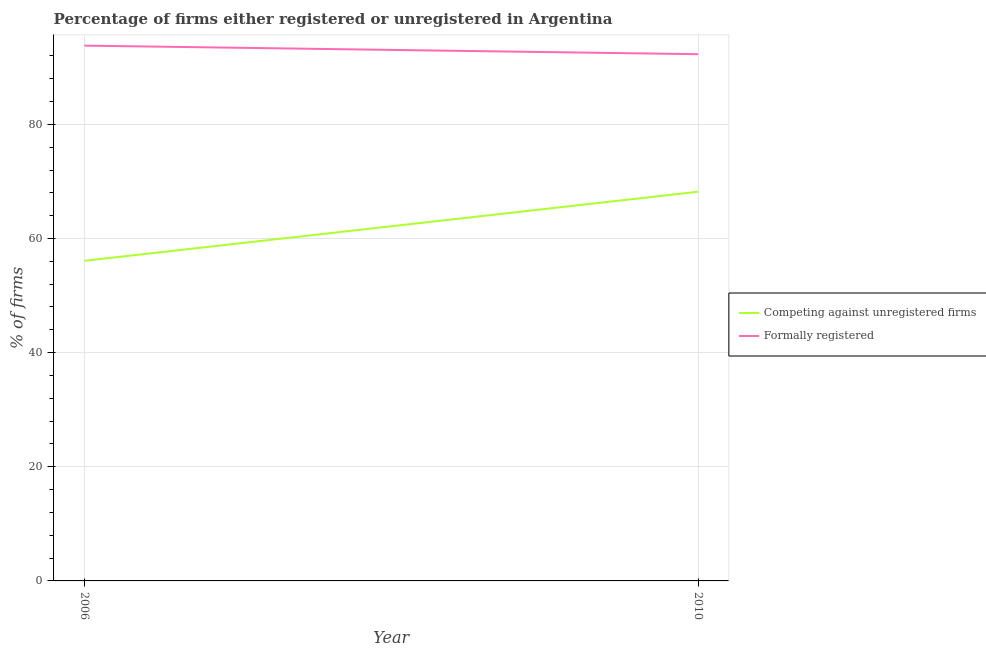What is the percentage of formally registered firms in 2010?
Ensure brevity in your answer.  92.3. Across all years, what is the maximum percentage of formally registered firms?
Keep it short and to the point. 93.8. Across all years, what is the minimum percentage of formally registered firms?
Make the answer very short. 92.3. In which year was the percentage of registered firms minimum?
Your answer should be compact. 2006. What is the total percentage of registered firms in the graph?
Give a very brief answer. 124.3. What is the difference between the percentage of registered firms in 2006 and that in 2010?
Keep it short and to the point. -12.1. What is the difference between the percentage of registered firms in 2006 and the percentage of formally registered firms in 2010?
Your answer should be compact. -36.2. What is the average percentage of formally registered firms per year?
Provide a short and direct response. 93.05. In the year 2006, what is the difference between the percentage of formally registered firms and percentage of registered firms?
Your answer should be compact. 37.7. In how many years, is the percentage of registered firms greater than 56 %?
Keep it short and to the point. 2. What is the ratio of the percentage of registered firms in 2006 to that in 2010?
Give a very brief answer. 0.82. In how many years, is the percentage of registered firms greater than the average percentage of registered firms taken over all years?
Provide a short and direct response. 1. Does the percentage of registered firms monotonically increase over the years?
Provide a short and direct response. Yes. Is the percentage of registered firms strictly greater than the percentage of formally registered firms over the years?
Keep it short and to the point. No. How are the legend labels stacked?
Make the answer very short. Vertical. What is the title of the graph?
Your answer should be very brief. Percentage of firms either registered or unregistered in Argentina. What is the label or title of the Y-axis?
Your answer should be very brief. % of firms. What is the % of firms of Competing against unregistered firms in 2006?
Your answer should be compact. 56.1. What is the % of firms in Formally registered in 2006?
Your answer should be very brief. 93.8. What is the % of firms in Competing against unregistered firms in 2010?
Your answer should be very brief. 68.2. What is the % of firms of Formally registered in 2010?
Your answer should be compact. 92.3. Across all years, what is the maximum % of firms in Competing against unregistered firms?
Give a very brief answer. 68.2. Across all years, what is the maximum % of firms of Formally registered?
Your answer should be compact. 93.8. Across all years, what is the minimum % of firms in Competing against unregistered firms?
Ensure brevity in your answer.  56.1. Across all years, what is the minimum % of firms of Formally registered?
Your response must be concise. 92.3. What is the total % of firms in Competing against unregistered firms in the graph?
Offer a terse response. 124.3. What is the total % of firms of Formally registered in the graph?
Keep it short and to the point. 186.1. What is the difference between the % of firms of Competing against unregistered firms in 2006 and that in 2010?
Your answer should be very brief. -12.1. What is the difference between the % of firms of Competing against unregistered firms in 2006 and the % of firms of Formally registered in 2010?
Ensure brevity in your answer.  -36.2. What is the average % of firms of Competing against unregistered firms per year?
Your answer should be very brief. 62.15. What is the average % of firms in Formally registered per year?
Your response must be concise. 93.05. In the year 2006, what is the difference between the % of firms of Competing against unregistered firms and % of firms of Formally registered?
Provide a short and direct response. -37.7. In the year 2010, what is the difference between the % of firms of Competing against unregistered firms and % of firms of Formally registered?
Your answer should be compact. -24.1. What is the ratio of the % of firms of Competing against unregistered firms in 2006 to that in 2010?
Make the answer very short. 0.82. What is the ratio of the % of firms of Formally registered in 2006 to that in 2010?
Your response must be concise. 1.02. What is the difference between the highest and the lowest % of firms in Competing against unregistered firms?
Provide a short and direct response. 12.1. 